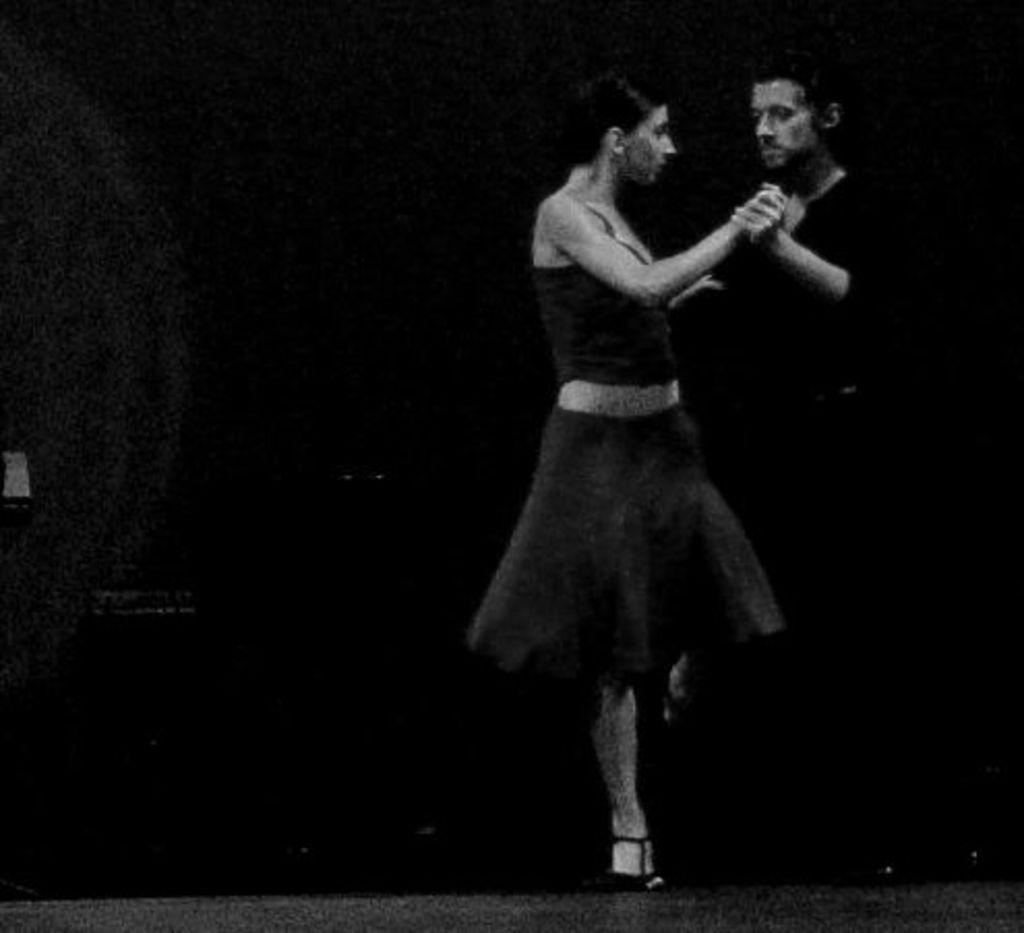Please provide a concise description of this image. This picture shows a man and woman dancing holding their hands. They wore black color dress. 